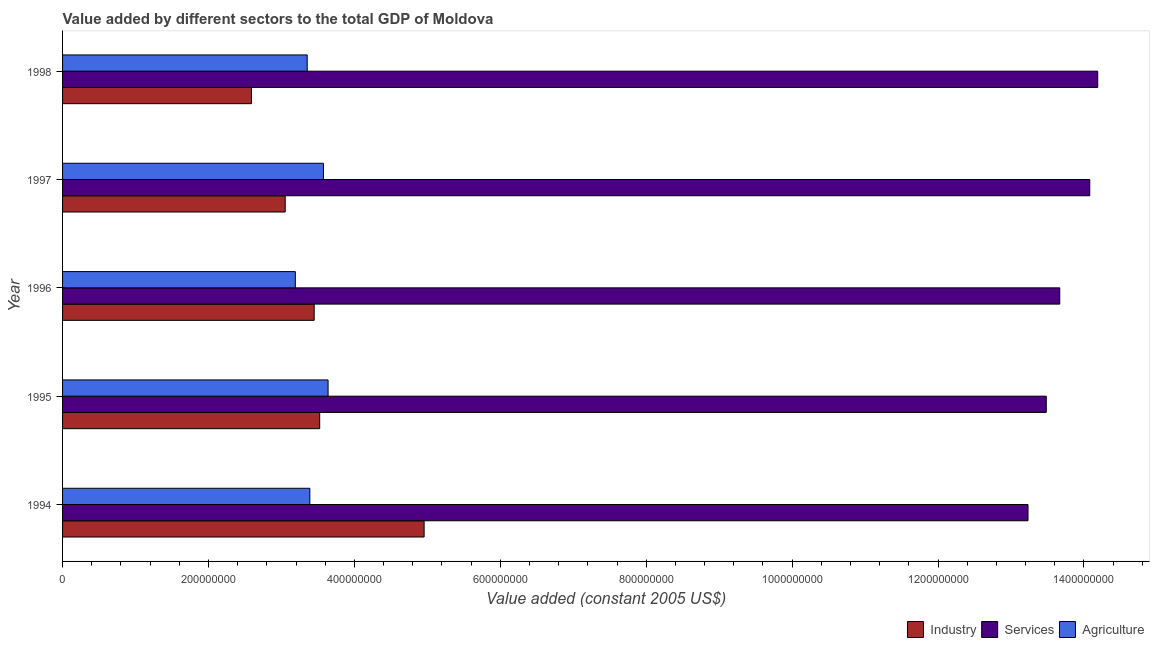How many different coloured bars are there?
Your answer should be compact. 3. How many groups of bars are there?
Provide a short and direct response. 5. How many bars are there on the 2nd tick from the bottom?
Make the answer very short. 3. What is the label of the 5th group of bars from the top?
Provide a succinct answer. 1994. What is the value added by agricultural sector in 1994?
Your answer should be very brief. 3.39e+08. Across all years, what is the maximum value added by industrial sector?
Offer a terse response. 4.96e+08. Across all years, what is the minimum value added by services?
Offer a very short reply. 1.32e+09. In which year was the value added by agricultural sector maximum?
Your answer should be very brief. 1995. What is the total value added by agricultural sector in the graph?
Make the answer very short. 1.71e+09. What is the difference between the value added by industrial sector in 1996 and that in 1998?
Your answer should be very brief. 8.60e+07. What is the difference between the value added by agricultural sector in 1994 and the value added by services in 1998?
Offer a very short reply. -1.08e+09. What is the average value added by industrial sector per year?
Give a very brief answer. 3.51e+08. In the year 1994, what is the difference between the value added by industrial sector and value added by agricultural sector?
Offer a very short reply. 1.57e+08. What is the ratio of the value added by industrial sector in 1996 to that in 1998?
Your response must be concise. 1.33. What is the difference between the highest and the second highest value added by agricultural sector?
Make the answer very short. 6.34e+06. What is the difference between the highest and the lowest value added by agricultural sector?
Give a very brief answer. 4.49e+07. In how many years, is the value added by industrial sector greater than the average value added by industrial sector taken over all years?
Keep it short and to the point. 2. Is the sum of the value added by services in 1994 and 1997 greater than the maximum value added by industrial sector across all years?
Provide a short and direct response. Yes. What does the 1st bar from the top in 1997 represents?
Provide a succinct answer. Agriculture. What does the 2nd bar from the bottom in 1995 represents?
Your response must be concise. Services. Are all the bars in the graph horizontal?
Offer a terse response. Yes. How many years are there in the graph?
Keep it short and to the point. 5. Does the graph contain any zero values?
Your answer should be compact. No. Does the graph contain grids?
Provide a succinct answer. No. Where does the legend appear in the graph?
Keep it short and to the point. Bottom right. What is the title of the graph?
Ensure brevity in your answer.  Value added by different sectors to the total GDP of Moldova. Does "Machinery" appear as one of the legend labels in the graph?
Ensure brevity in your answer.  No. What is the label or title of the X-axis?
Provide a short and direct response. Value added (constant 2005 US$). What is the Value added (constant 2005 US$) of Industry in 1994?
Offer a terse response. 4.96e+08. What is the Value added (constant 2005 US$) in Services in 1994?
Your answer should be very brief. 1.32e+09. What is the Value added (constant 2005 US$) in Agriculture in 1994?
Your answer should be compact. 3.39e+08. What is the Value added (constant 2005 US$) in Industry in 1995?
Provide a short and direct response. 3.52e+08. What is the Value added (constant 2005 US$) in Services in 1995?
Provide a succinct answer. 1.35e+09. What is the Value added (constant 2005 US$) of Agriculture in 1995?
Offer a very short reply. 3.64e+08. What is the Value added (constant 2005 US$) of Industry in 1996?
Give a very brief answer. 3.45e+08. What is the Value added (constant 2005 US$) of Services in 1996?
Offer a terse response. 1.37e+09. What is the Value added (constant 2005 US$) in Agriculture in 1996?
Give a very brief answer. 3.19e+08. What is the Value added (constant 2005 US$) in Industry in 1997?
Offer a very short reply. 3.05e+08. What is the Value added (constant 2005 US$) of Services in 1997?
Make the answer very short. 1.41e+09. What is the Value added (constant 2005 US$) of Agriculture in 1997?
Your answer should be very brief. 3.58e+08. What is the Value added (constant 2005 US$) in Industry in 1998?
Ensure brevity in your answer.  2.59e+08. What is the Value added (constant 2005 US$) of Services in 1998?
Offer a very short reply. 1.42e+09. What is the Value added (constant 2005 US$) in Agriculture in 1998?
Provide a short and direct response. 3.35e+08. Across all years, what is the maximum Value added (constant 2005 US$) of Industry?
Offer a very short reply. 4.96e+08. Across all years, what is the maximum Value added (constant 2005 US$) in Services?
Give a very brief answer. 1.42e+09. Across all years, what is the maximum Value added (constant 2005 US$) of Agriculture?
Your answer should be very brief. 3.64e+08. Across all years, what is the minimum Value added (constant 2005 US$) in Industry?
Give a very brief answer. 2.59e+08. Across all years, what is the minimum Value added (constant 2005 US$) in Services?
Your answer should be compact. 1.32e+09. Across all years, what is the minimum Value added (constant 2005 US$) of Agriculture?
Ensure brevity in your answer.  3.19e+08. What is the total Value added (constant 2005 US$) of Industry in the graph?
Give a very brief answer. 1.76e+09. What is the total Value added (constant 2005 US$) of Services in the graph?
Offer a terse response. 6.87e+09. What is the total Value added (constant 2005 US$) of Agriculture in the graph?
Offer a very short reply. 1.71e+09. What is the difference between the Value added (constant 2005 US$) of Industry in 1994 and that in 1995?
Ensure brevity in your answer.  1.43e+08. What is the difference between the Value added (constant 2005 US$) of Services in 1994 and that in 1995?
Your answer should be very brief. -2.50e+07. What is the difference between the Value added (constant 2005 US$) in Agriculture in 1994 and that in 1995?
Give a very brief answer. -2.50e+07. What is the difference between the Value added (constant 2005 US$) of Industry in 1994 and that in 1996?
Offer a very short reply. 1.51e+08. What is the difference between the Value added (constant 2005 US$) in Services in 1994 and that in 1996?
Make the answer very short. -4.35e+07. What is the difference between the Value added (constant 2005 US$) in Agriculture in 1994 and that in 1996?
Ensure brevity in your answer.  1.99e+07. What is the difference between the Value added (constant 2005 US$) in Industry in 1994 and that in 1997?
Your answer should be very brief. 1.90e+08. What is the difference between the Value added (constant 2005 US$) of Services in 1994 and that in 1997?
Offer a terse response. -8.47e+07. What is the difference between the Value added (constant 2005 US$) of Agriculture in 1994 and that in 1997?
Offer a very short reply. -1.86e+07. What is the difference between the Value added (constant 2005 US$) in Industry in 1994 and that in 1998?
Ensure brevity in your answer.  2.37e+08. What is the difference between the Value added (constant 2005 US$) of Services in 1994 and that in 1998?
Give a very brief answer. -9.56e+07. What is the difference between the Value added (constant 2005 US$) in Agriculture in 1994 and that in 1998?
Your answer should be compact. 3.62e+06. What is the difference between the Value added (constant 2005 US$) of Industry in 1995 and that in 1996?
Your answer should be very brief. 7.55e+06. What is the difference between the Value added (constant 2005 US$) of Services in 1995 and that in 1996?
Keep it short and to the point. -1.85e+07. What is the difference between the Value added (constant 2005 US$) in Agriculture in 1995 and that in 1996?
Give a very brief answer. 4.49e+07. What is the difference between the Value added (constant 2005 US$) of Industry in 1995 and that in 1997?
Your answer should be compact. 4.72e+07. What is the difference between the Value added (constant 2005 US$) of Services in 1995 and that in 1997?
Your answer should be compact. -5.96e+07. What is the difference between the Value added (constant 2005 US$) of Agriculture in 1995 and that in 1997?
Offer a very short reply. 6.34e+06. What is the difference between the Value added (constant 2005 US$) in Industry in 1995 and that in 1998?
Keep it short and to the point. 9.35e+07. What is the difference between the Value added (constant 2005 US$) of Services in 1995 and that in 1998?
Ensure brevity in your answer.  -7.05e+07. What is the difference between the Value added (constant 2005 US$) in Agriculture in 1995 and that in 1998?
Make the answer very short. 2.86e+07. What is the difference between the Value added (constant 2005 US$) of Industry in 1996 and that in 1997?
Offer a very short reply. 3.97e+07. What is the difference between the Value added (constant 2005 US$) in Services in 1996 and that in 1997?
Keep it short and to the point. -4.11e+07. What is the difference between the Value added (constant 2005 US$) of Agriculture in 1996 and that in 1997?
Offer a terse response. -3.85e+07. What is the difference between the Value added (constant 2005 US$) in Industry in 1996 and that in 1998?
Ensure brevity in your answer.  8.60e+07. What is the difference between the Value added (constant 2005 US$) in Services in 1996 and that in 1998?
Offer a very short reply. -5.21e+07. What is the difference between the Value added (constant 2005 US$) in Agriculture in 1996 and that in 1998?
Keep it short and to the point. -1.63e+07. What is the difference between the Value added (constant 2005 US$) in Industry in 1997 and that in 1998?
Ensure brevity in your answer.  4.63e+07. What is the difference between the Value added (constant 2005 US$) of Services in 1997 and that in 1998?
Offer a terse response. -1.09e+07. What is the difference between the Value added (constant 2005 US$) in Agriculture in 1997 and that in 1998?
Keep it short and to the point. 2.23e+07. What is the difference between the Value added (constant 2005 US$) of Industry in 1994 and the Value added (constant 2005 US$) of Services in 1995?
Make the answer very short. -8.53e+08. What is the difference between the Value added (constant 2005 US$) of Industry in 1994 and the Value added (constant 2005 US$) of Agriculture in 1995?
Your answer should be compact. 1.32e+08. What is the difference between the Value added (constant 2005 US$) of Services in 1994 and the Value added (constant 2005 US$) of Agriculture in 1995?
Keep it short and to the point. 9.59e+08. What is the difference between the Value added (constant 2005 US$) of Industry in 1994 and the Value added (constant 2005 US$) of Services in 1996?
Keep it short and to the point. -8.71e+08. What is the difference between the Value added (constant 2005 US$) in Industry in 1994 and the Value added (constant 2005 US$) in Agriculture in 1996?
Provide a short and direct response. 1.77e+08. What is the difference between the Value added (constant 2005 US$) in Services in 1994 and the Value added (constant 2005 US$) in Agriculture in 1996?
Give a very brief answer. 1.00e+09. What is the difference between the Value added (constant 2005 US$) in Industry in 1994 and the Value added (constant 2005 US$) in Services in 1997?
Make the answer very short. -9.12e+08. What is the difference between the Value added (constant 2005 US$) of Industry in 1994 and the Value added (constant 2005 US$) of Agriculture in 1997?
Ensure brevity in your answer.  1.38e+08. What is the difference between the Value added (constant 2005 US$) of Services in 1994 and the Value added (constant 2005 US$) of Agriculture in 1997?
Provide a succinct answer. 9.66e+08. What is the difference between the Value added (constant 2005 US$) of Industry in 1994 and the Value added (constant 2005 US$) of Services in 1998?
Your answer should be very brief. -9.23e+08. What is the difference between the Value added (constant 2005 US$) of Industry in 1994 and the Value added (constant 2005 US$) of Agriculture in 1998?
Provide a short and direct response. 1.60e+08. What is the difference between the Value added (constant 2005 US$) in Services in 1994 and the Value added (constant 2005 US$) in Agriculture in 1998?
Make the answer very short. 9.88e+08. What is the difference between the Value added (constant 2005 US$) of Industry in 1995 and the Value added (constant 2005 US$) of Services in 1996?
Make the answer very short. -1.01e+09. What is the difference between the Value added (constant 2005 US$) in Industry in 1995 and the Value added (constant 2005 US$) in Agriculture in 1996?
Your response must be concise. 3.34e+07. What is the difference between the Value added (constant 2005 US$) in Services in 1995 and the Value added (constant 2005 US$) in Agriculture in 1996?
Your answer should be very brief. 1.03e+09. What is the difference between the Value added (constant 2005 US$) in Industry in 1995 and the Value added (constant 2005 US$) in Services in 1997?
Your answer should be compact. -1.06e+09. What is the difference between the Value added (constant 2005 US$) of Industry in 1995 and the Value added (constant 2005 US$) of Agriculture in 1997?
Give a very brief answer. -5.15e+06. What is the difference between the Value added (constant 2005 US$) in Services in 1995 and the Value added (constant 2005 US$) in Agriculture in 1997?
Give a very brief answer. 9.91e+08. What is the difference between the Value added (constant 2005 US$) in Industry in 1995 and the Value added (constant 2005 US$) in Services in 1998?
Keep it short and to the point. -1.07e+09. What is the difference between the Value added (constant 2005 US$) of Industry in 1995 and the Value added (constant 2005 US$) of Agriculture in 1998?
Keep it short and to the point. 1.71e+07. What is the difference between the Value added (constant 2005 US$) in Services in 1995 and the Value added (constant 2005 US$) in Agriculture in 1998?
Your response must be concise. 1.01e+09. What is the difference between the Value added (constant 2005 US$) in Industry in 1996 and the Value added (constant 2005 US$) in Services in 1997?
Provide a short and direct response. -1.06e+09. What is the difference between the Value added (constant 2005 US$) of Industry in 1996 and the Value added (constant 2005 US$) of Agriculture in 1997?
Offer a very short reply. -1.27e+07. What is the difference between the Value added (constant 2005 US$) in Services in 1996 and the Value added (constant 2005 US$) in Agriculture in 1997?
Provide a succinct answer. 1.01e+09. What is the difference between the Value added (constant 2005 US$) of Industry in 1996 and the Value added (constant 2005 US$) of Services in 1998?
Ensure brevity in your answer.  -1.07e+09. What is the difference between the Value added (constant 2005 US$) of Industry in 1996 and the Value added (constant 2005 US$) of Agriculture in 1998?
Make the answer very short. 9.55e+06. What is the difference between the Value added (constant 2005 US$) of Services in 1996 and the Value added (constant 2005 US$) of Agriculture in 1998?
Provide a succinct answer. 1.03e+09. What is the difference between the Value added (constant 2005 US$) in Industry in 1997 and the Value added (constant 2005 US$) in Services in 1998?
Make the answer very short. -1.11e+09. What is the difference between the Value added (constant 2005 US$) of Industry in 1997 and the Value added (constant 2005 US$) of Agriculture in 1998?
Ensure brevity in your answer.  -3.01e+07. What is the difference between the Value added (constant 2005 US$) of Services in 1997 and the Value added (constant 2005 US$) of Agriculture in 1998?
Offer a terse response. 1.07e+09. What is the average Value added (constant 2005 US$) in Industry per year?
Your response must be concise. 3.51e+08. What is the average Value added (constant 2005 US$) in Services per year?
Make the answer very short. 1.37e+09. What is the average Value added (constant 2005 US$) in Agriculture per year?
Offer a very short reply. 3.43e+08. In the year 1994, what is the difference between the Value added (constant 2005 US$) of Industry and Value added (constant 2005 US$) of Services?
Provide a succinct answer. -8.28e+08. In the year 1994, what is the difference between the Value added (constant 2005 US$) in Industry and Value added (constant 2005 US$) in Agriculture?
Keep it short and to the point. 1.57e+08. In the year 1994, what is the difference between the Value added (constant 2005 US$) in Services and Value added (constant 2005 US$) in Agriculture?
Your response must be concise. 9.84e+08. In the year 1995, what is the difference between the Value added (constant 2005 US$) in Industry and Value added (constant 2005 US$) in Services?
Your answer should be very brief. -9.96e+08. In the year 1995, what is the difference between the Value added (constant 2005 US$) in Industry and Value added (constant 2005 US$) in Agriculture?
Your answer should be very brief. -1.15e+07. In the year 1995, what is the difference between the Value added (constant 2005 US$) of Services and Value added (constant 2005 US$) of Agriculture?
Ensure brevity in your answer.  9.84e+08. In the year 1996, what is the difference between the Value added (constant 2005 US$) in Industry and Value added (constant 2005 US$) in Services?
Offer a very short reply. -1.02e+09. In the year 1996, what is the difference between the Value added (constant 2005 US$) in Industry and Value added (constant 2005 US$) in Agriculture?
Provide a short and direct response. 2.58e+07. In the year 1996, what is the difference between the Value added (constant 2005 US$) in Services and Value added (constant 2005 US$) in Agriculture?
Keep it short and to the point. 1.05e+09. In the year 1997, what is the difference between the Value added (constant 2005 US$) in Industry and Value added (constant 2005 US$) in Services?
Offer a terse response. -1.10e+09. In the year 1997, what is the difference between the Value added (constant 2005 US$) in Industry and Value added (constant 2005 US$) in Agriculture?
Offer a very short reply. -5.24e+07. In the year 1997, what is the difference between the Value added (constant 2005 US$) of Services and Value added (constant 2005 US$) of Agriculture?
Give a very brief answer. 1.05e+09. In the year 1998, what is the difference between the Value added (constant 2005 US$) of Industry and Value added (constant 2005 US$) of Services?
Keep it short and to the point. -1.16e+09. In the year 1998, what is the difference between the Value added (constant 2005 US$) in Industry and Value added (constant 2005 US$) in Agriculture?
Ensure brevity in your answer.  -7.64e+07. In the year 1998, what is the difference between the Value added (constant 2005 US$) in Services and Value added (constant 2005 US$) in Agriculture?
Your answer should be very brief. 1.08e+09. What is the ratio of the Value added (constant 2005 US$) of Industry in 1994 to that in 1995?
Your response must be concise. 1.41. What is the ratio of the Value added (constant 2005 US$) of Services in 1994 to that in 1995?
Offer a terse response. 0.98. What is the ratio of the Value added (constant 2005 US$) of Agriculture in 1994 to that in 1995?
Make the answer very short. 0.93. What is the ratio of the Value added (constant 2005 US$) of Industry in 1994 to that in 1996?
Your answer should be very brief. 1.44. What is the ratio of the Value added (constant 2005 US$) in Services in 1994 to that in 1996?
Give a very brief answer. 0.97. What is the ratio of the Value added (constant 2005 US$) of Agriculture in 1994 to that in 1996?
Give a very brief answer. 1.06. What is the ratio of the Value added (constant 2005 US$) of Industry in 1994 to that in 1997?
Make the answer very short. 1.62. What is the ratio of the Value added (constant 2005 US$) of Services in 1994 to that in 1997?
Your response must be concise. 0.94. What is the ratio of the Value added (constant 2005 US$) of Agriculture in 1994 to that in 1997?
Your response must be concise. 0.95. What is the ratio of the Value added (constant 2005 US$) in Industry in 1994 to that in 1998?
Offer a terse response. 1.91. What is the ratio of the Value added (constant 2005 US$) in Services in 1994 to that in 1998?
Provide a short and direct response. 0.93. What is the ratio of the Value added (constant 2005 US$) in Agriculture in 1994 to that in 1998?
Your response must be concise. 1.01. What is the ratio of the Value added (constant 2005 US$) of Industry in 1995 to that in 1996?
Your response must be concise. 1.02. What is the ratio of the Value added (constant 2005 US$) in Services in 1995 to that in 1996?
Ensure brevity in your answer.  0.99. What is the ratio of the Value added (constant 2005 US$) of Agriculture in 1995 to that in 1996?
Your response must be concise. 1.14. What is the ratio of the Value added (constant 2005 US$) of Industry in 1995 to that in 1997?
Your answer should be compact. 1.15. What is the ratio of the Value added (constant 2005 US$) in Services in 1995 to that in 1997?
Your answer should be compact. 0.96. What is the ratio of the Value added (constant 2005 US$) of Agriculture in 1995 to that in 1997?
Keep it short and to the point. 1.02. What is the ratio of the Value added (constant 2005 US$) of Industry in 1995 to that in 1998?
Give a very brief answer. 1.36. What is the ratio of the Value added (constant 2005 US$) in Services in 1995 to that in 1998?
Your answer should be very brief. 0.95. What is the ratio of the Value added (constant 2005 US$) of Agriculture in 1995 to that in 1998?
Your answer should be very brief. 1.09. What is the ratio of the Value added (constant 2005 US$) of Industry in 1996 to that in 1997?
Provide a succinct answer. 1.13. What is the ratio of the Value added (constant 2005 US$) in Services in 1996 to that in 1997?
Make the answer very short. 0.97. What is the ratio of the Value added (constant 2005 US$) in Agriculture in 1996 to that in 1997?
Ensure brevity in your answer.  0.89. What is the ratio of the Value added (constant 2005 US$) in Industry in 1996 to that in 1998?
Your answer should be compact. 1.33. What is the ratio of the Value added (constant 2005 US$) in Services in 1996 to that in 1998?
Give a very brief answer. 0.96. What is the ratio of the Value added (constant 2005 US$) of Agriculture in 1996 to that in 1998?
Offer a terse response. 0.95. What is the ratio of the Value added (constant 2005 US$) in Industry in 1997 to that in 1998?
Provide a succinct answer. 1.18. What is the ratio of the Value added (constant 2005 US$) in Services in 1997 to that in 1998?
Your answer should be very brief. 0.99. What is the ratio of the Value added (constant 2005 US$) in Agriculture in 1997 to that in 1998?
Make the answer very short. 1.07. What is the difference between the highest and the second highest Value added (constant 2005 US$) of Industry?
Your answer should be compact. 1.43e+08. What is the difference between the highest and the second highest Value added (constant 2005 US$) of Services?
Offer a terse response. 1.09e+07. What is the difference between the highest and the second highest Value added (constant 2005 US$) in Agriculture?
Ensure brevity in your answer.  6.34e+06. What is the difference between the highest and the lowest Value added (constant 2005 US$) in Industry?
Offer a very short reply. 2.37e+08. What is the difference between the highest and the lowest Value added (constant 2005 US$) of Services?
Provide a succinct answer. 9.56e+07. What is the difference between the highest and the lowest Value added (constant 2005 US$) of Agriculture?
Your response must be concise. 4.49e+07. 